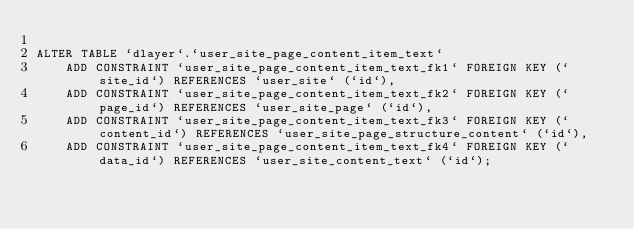<code> <loc_0><loc_0><loc_500><loc_500><_SQL_>
ALTER TABLE `dlayer`.`user_site_page_content_item_text`
	ADD CONSTRAINT `user_site_page_content_item_text_fk1` FOREIGN KEY (`site_id`) REFERENCES `user_site` (`id`),
	ADD CONSTRAINT `user_site_page_content_item_text_fk2` FOREIGN KEY (`page_id`) REFERENCES `user_site_page` (`id`),
	ADD CONSTRAINT `user_site_page_content_item_text_fk3` FOREIGN KEY (`content_id`) REFERENCES `user_site_page_structure_content` (`id`),
	ADD CONSTRAINT `user_site_page_content_item_text_fk4` FOREIGN KEY (`data_id`) REFERENCES `user_site_content_text` (`id`);
</code> 